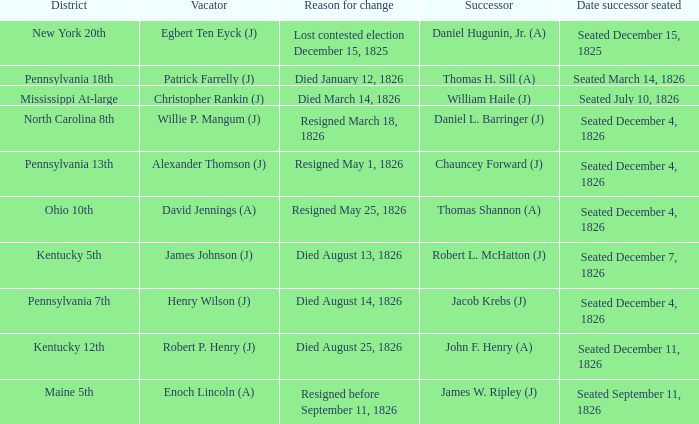Name the vacator for died august 13, 1826 James Johnson (J). Parse the table in full. {'header': ['District', 'Vacator', 'Reason for change', 'Successor', 'Date successor seated'], 'rows': [['New York 20th', 'Egbert Ten Eyck (J)', 'Lost contested election December 15, 1825', 'Daniel Hugunin, Jr. (A)', 'Seated December 15, 1825'], ['Pennsylvania 18th', 'Patrick Farrelly (J)', 'Died January 12, 1826', 'Thomas H. Sill (A)', 'Seated March 14, 1826'], ['Mississippi At-large', 'Christopher Rankin (J)', 'Died March 14, 1826', 'William Haile (J)', 'Seated July 10, 1826'], ['North Carolina 8th', 'Willie P. Mangum (J)', 'Resigned March 18, 1826', 'Daniel L. Barringer (J)', 'Seated December 4, 1826'], ['Pennsylvania 13th', 'Alexander Thomson (J)', 'Resigned May 1, 1826', 'Chauncey Forward (J)', 'Seated December 4, 1826'], ['Ohio 10th', 'David Jennings (A)', 'Resigned May 25, 1826', 'Thomas Shannon (A)', 'Seated December 4, 1826'], ['Kentucky 5th', 'James Johnson (J)', 'Died August 13, 1826', 'Robert L. McHatton (J)', 'Seated December 7, 1826'], ['Pennsylvania 7th', 'Henry Wilson (J)', 'Died August 14, 1826', 'Jacob Krebs (J)', 'Seated December 4, 1826'], ['Kentucky 12th', 'Robert P. Henry (J)', 'Died August 25, 1826', 'John F. Henry (A)', 'Seated December 11, 1826'], ['Maine 5th', 'Enoch Lincoln (A)', 'Resigned before September 11, 1826', 'James W. Ripley (J)', 'Seated September 11, 1826']]} 